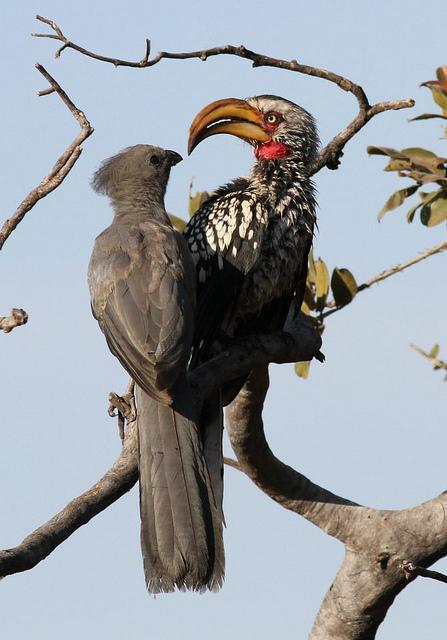How many birds are visible?
Give a very brief answer. 2. How many pizzas have been half-eaten?
Give a very brief answer. 0. 